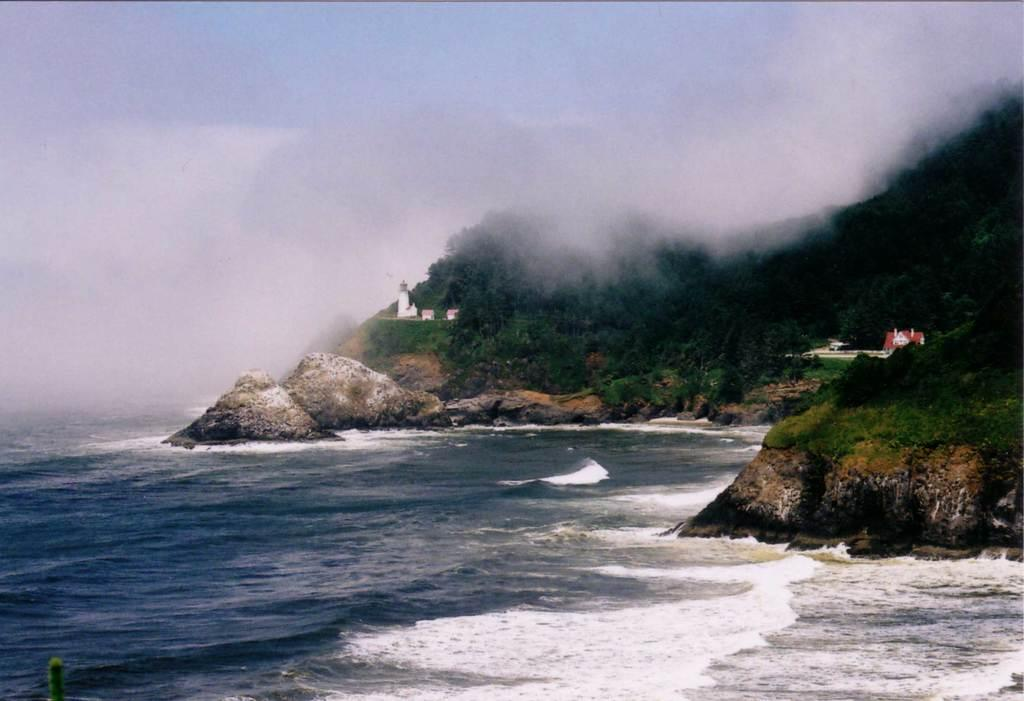What type of landscape is depicted in the image? The image shows a mountain with trees on it. What is located at the bottom of the mountain? There is a sea at the bottom of the image. What is the condition of the sky in the image? The sky is covered with clouds. Can you see a coach driving through the trees on the mountain in the image? There is no coach present in the image; it features a mountain with trees and a sea at the bottom. What type of tool is being used to smash the clouds in the sky in the image? There is no tool or action being used to smash the clouds in the sky in the image; the clouds are simply present in the sky. 